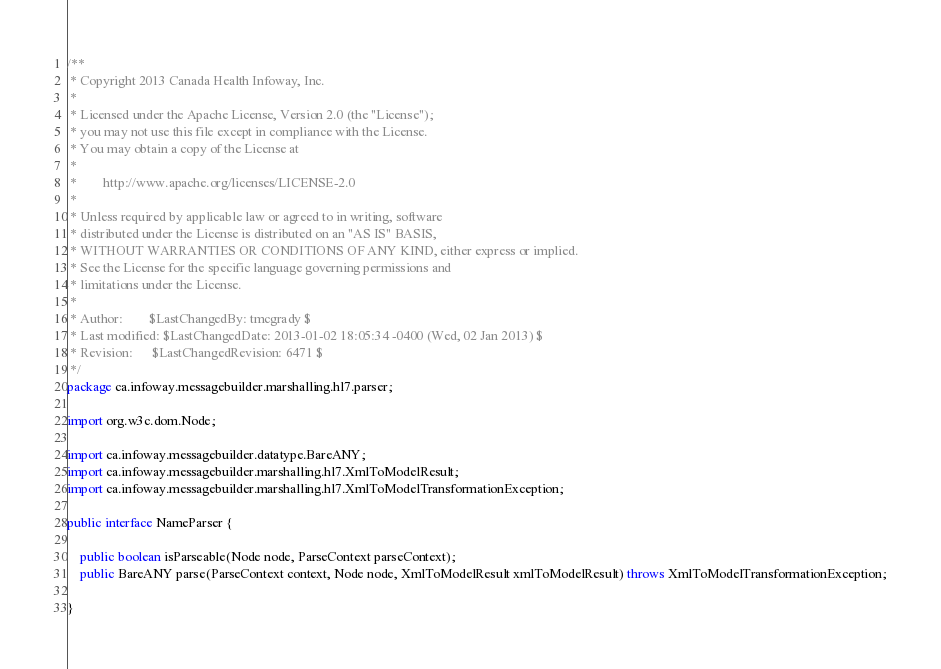<code> <loc_0><loc_0><loc_500><loc_500><_Java_>/**
 * Copyright 2013 Canada Health Infoway, Inc.
 *
 * Licensed under the Apache License, Version 2.0 (the "License");
 * you may not use this file except in compliance with the License.
 * You may obtain a copy of the License at
 *
 *        http://www.apache.org/licenses/LICENSE-2.0
 *
 * Unless required by applicable law or agreed to in writing, software
 * distributed under the License is distributed on an "AS IS" BASIS,
 * WITHOUT WARRANTIES OR CONDITIONS OF ANY KIND, either express or implied.
 * See the License for the specific language governing permissions and
 * limitations under the License.
 *
 * Author:        $LastChangedBy: tmcgrady $
 * Last modified: $LastChangedDate: 2013-01-02 18:05:34 -0400 (Wed, 02 Jan 2013) $
 * Revision:      $LastChangedRevision: 6471 $
 */
package ca.infoway.messagebuilder.marshalling.hl7.parser;

import org.w3c.dom.Node;

import ca.infoway.messagebuilder.datatype.BareANY;
import ca.infoway.messagebuilder.marshalling.hl7.XmlToModelResult;
import ca.infoway.messagebuilder.marshalling.hl7.XmlToModelTransformationException;

public interface NameParser {
	
    public boolean isParseable(Node node, ParseContext parseContext);
    public BareANY parse(ParseContext context, Node node, XmlToModelResult xmlToModelResult) throws XmlToModelTransformationException;

}
</code> 